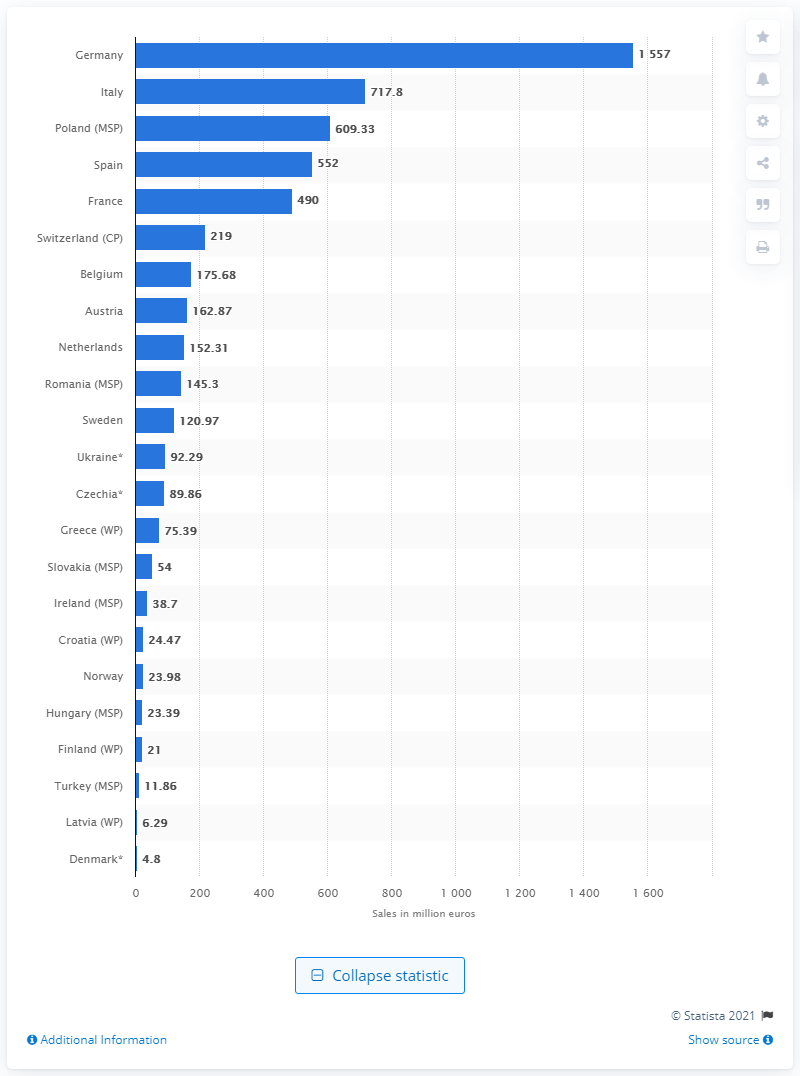Outline some significant characteristics in this image. In 2017, the sales of cough and cold medications in Italy totaled 717.8 million euros. 